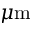Convert formula to latex. <formula><loc_0><loc_0><loc_500><loc_500>\mu m</formula> 